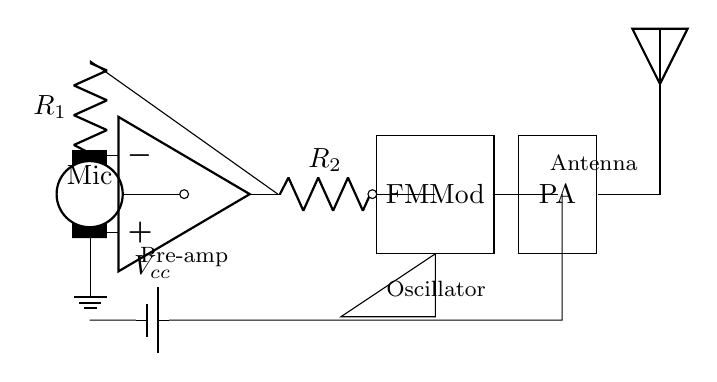What is the function of the component labeled as "Mic"? The "Mic" is the microphone that converts sound waves into electrical signals, which are then amplified and processed in the circuit.
Answer: Microphone What does "Vcc" represent in this circuit? "Vcc" represents the supply voltage provided to the circuit components to operate them. This is typically a positive voltage needed for the functionality of the entire circuit.
Answer: Supply voltage How many resistors are in the circuit? There are two resistors indicated by "R1" and "R2" in the circuit, which are used to set gain and regulate the signal.
Answer: Two What is the role of the "PA"? The "PA" stands for power amplifier, which increases the power of the modulated signal before it is transmitted through the antenna.
Answer: Power amplifier What type of modulation is indicated in the diagram? The modulation type indicated in the diagram is frequency modulation, as denoted by "FM Mod" block.
Answer: Frequency modulation What is the purpose of the antenna in this circuit? The antenna is used to transmit the modulated radio signal wirelessly to a receiver, enabling wireless communication.
Answer: Transmit signal 